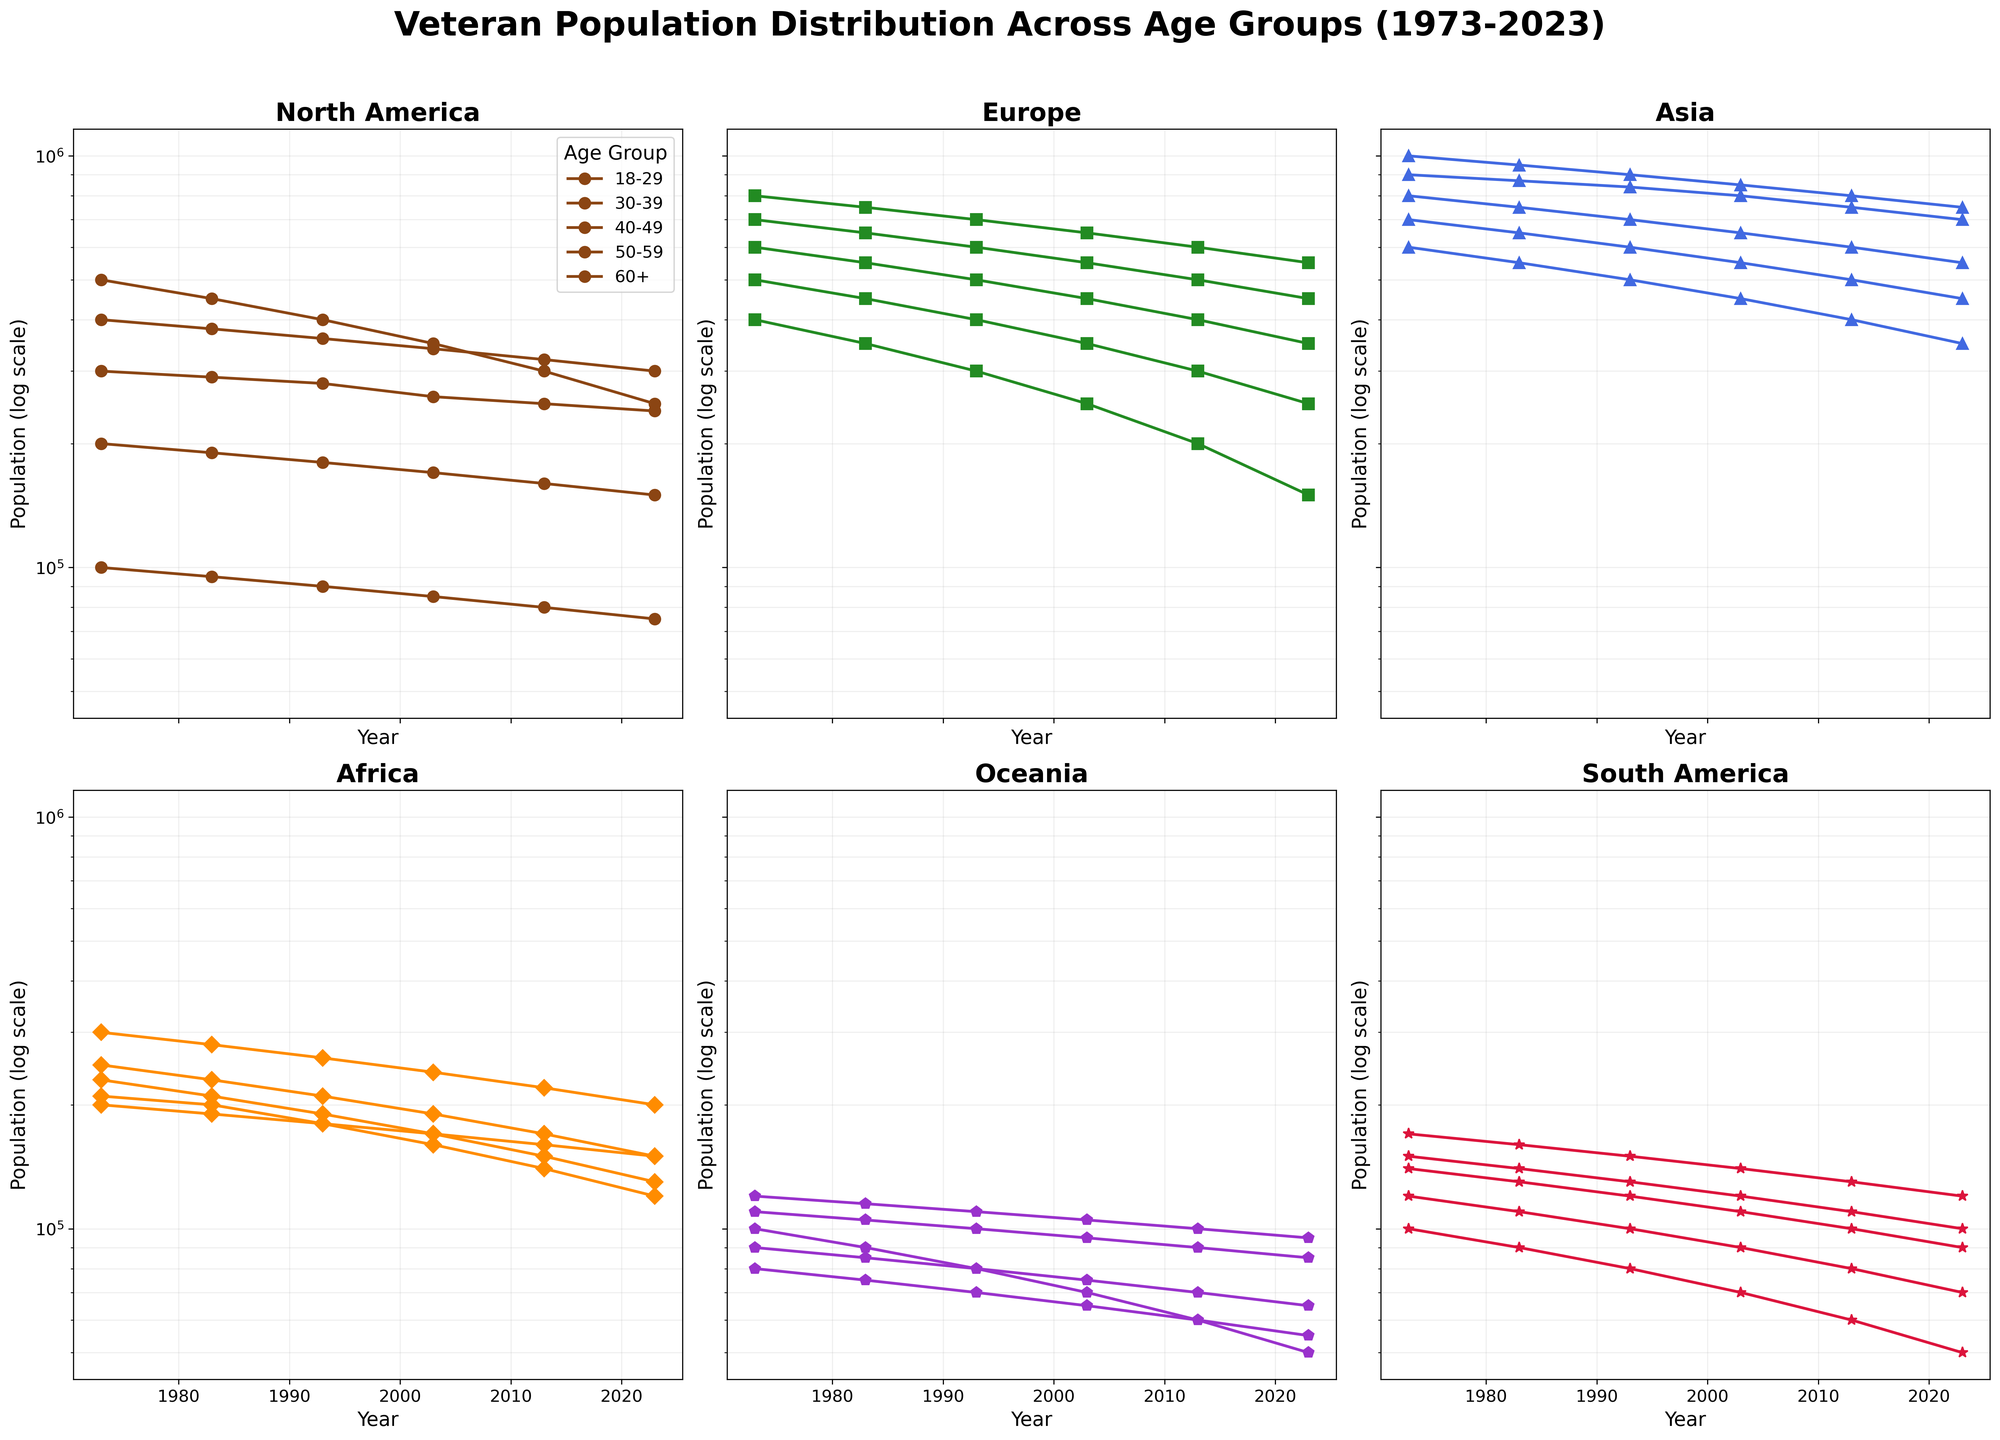How does the veteran population in North America for the age group 60+ change from 1973 to 2023? To determine this, look at the semilog plot for North America and identify the 60+ age group's line. Note the population values in 1973 and 2023. The veteran population decreases from 100,000 in 1973 to 75,000 in 2023.
Answer: Decreases Which region had the highest veteran population in the age group 30-39 in 2023? Examine the 2023 data points across all subplots for the 30-39 age group and compare the values. Asia has the highest veteran population for this group at 700,000.
Answer: Asia Compare the veteran population trend in Asia for the age group 18-29 with that of Oceania from 2003 to 2013. Inspect the semilog plots for Asia and Oceania. The population in Asia declines from 850,000 in 2003 to 800,000 in 2013, while in Oceania it declines from 70,000 to 60,000. Both regions show a decreasing trend.
Answer: Both decreasing What is the overall trend for the veteran population in Europe across all age groups from 1973 to 2023? Check all the lines in the Europe subplot and observe their behavior over time. Across all age groups, the trend is a general decline in veteran population.
Answer: General decline Which age group in South America sees the least change in veteran population from 1973 to 2023? Analyze the changes in each age group's line in the South America subplot. The age group 60+ decreases from 100,000 to 50,000, showing the least variation.
Answer: 60+ In which decade did the veteran population in Africa for the age group 50-59 show the highest increase? Identify the decade intervals on the Africa subplot and compare the population values for the 50-59 age group. From 1973 to 1983, it increased from 230,000 to 210,000 but decreased in subsequent decades.
Answer: 1973-1983 How does the veteran population in Oceania for the age group 30-39 change from 1993 to 2023? Examine the semilog plot for Oceania and find the population values for the 30-39 age group in 1993 and 2023. It decreases from 110,000 to 95,000.
Answer: Decreases Which age group in Asia shows the most dramatic decrease in veteran population from 1973 to 2023? Check the semilog plot for Asia and compare the starting and ending points of each age group's line. The age group 60+ decreases from 600,000 to 350,000, showing the most significant drop.
Answer: 60+ What are the median veteran population values in Europe for all age groups in 1993? Extract the 1993 data for Europe across all age groups and find the middle value for the sorted list 300,000, 400,000, 500,000, 600,000, 700,000; the median is 500,000.
Answer: 500,000 Is the decline in veteran population steeper in North America or Europe for the age group 50-59 from 1973 to 2023? By comparing the slopes of the lines for 50-59 in North America and Europe from 1973 to 2023 on the respective plots, North America goes from 200,000 to 150,000, and Europe from 500,000 to 250,000. Europe has a steeper decline.
Answer: Europe 